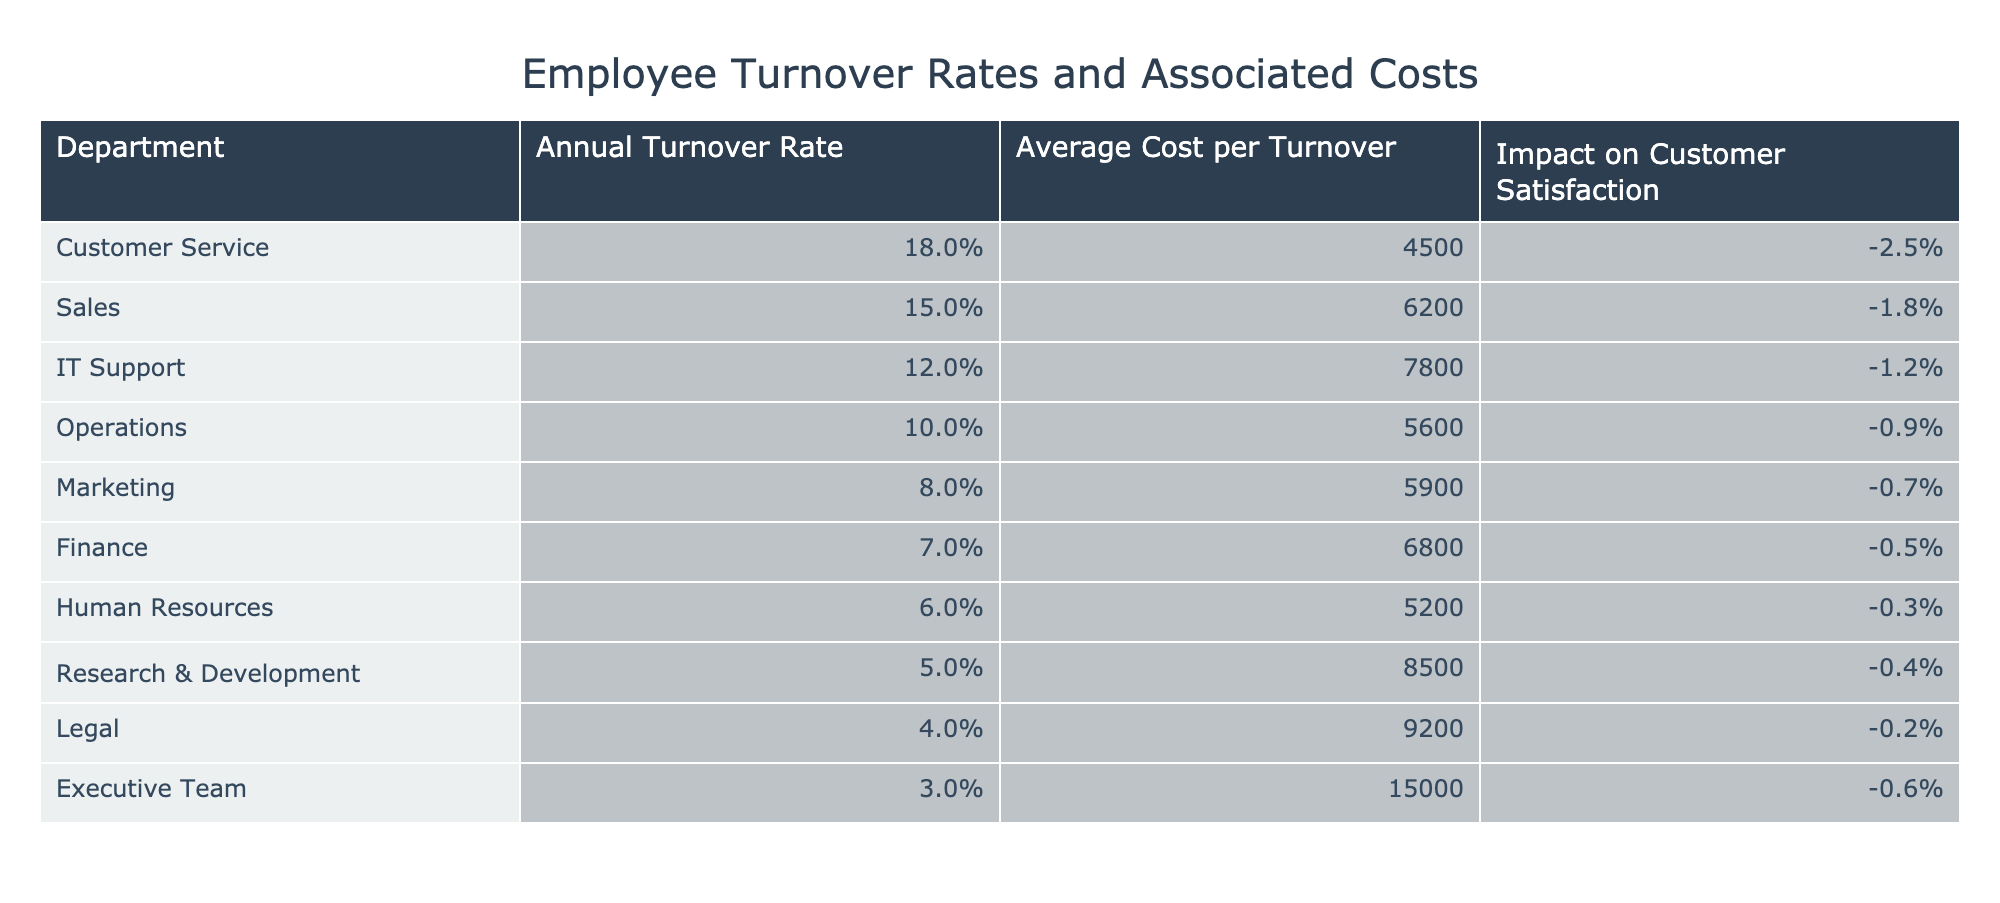What is the annual turnover rate for the Customer Service department? The table shows the "Annual Turnover Rate" for the Customer Service department as 18%.
Answer: 18% Which department has the highest average cost per turnover? The table lists the average cost per turnover for each department. The Executive Team has the highest cost at $15,000.
Answer: $15,000 What is the total impact on customer satisfaction of the Sales and IT Support departments combined? The impact on customer satisfaction for Sales is -1.8% and for IT Support is -1.2%. Adding these gives -1.8% + -1.2% = -3.0%.
Answer: -3.0% Is the average cost per turnover for the Marketing department lower than that of the Finance department? The average cost per turnover for Marketing is $5,900 and for Finance is $6,800. Since $5,900 is less than $6,800, the statement is true.
Answer: Yes How does the turnover rate of the Operations department compare to that of the Marketing department? The Operations department has a turnover rate of 10%, while the Marketing department has a turnover rate of 8%. Thus, Operations has a higher turnover rate than Marketing.
Answer: Higher What is the average annual turnover rate for departments with an impact on customer satisfaction greater than -1%? The departments with an impact greater than -1% are Finance (7%), Human Resources (6%), Research & Development (5%), Legal (4%), and Executive Team (3%). The average is (7 + 6 + 5 + 4 + 3) / 5 = 25 / 5 = 5%.
Answer: 5% What is the difference in average cost per turnover between the departments with the highest and lowest turnover rates? The department with the highest turnover rate is Customer Service with $4,500, and the lowest is Executive Team with $15,000. The difference is $15,000 - $4,500 = $10,500.
Answer: $10,500 Is it true that the IT Support department has a negative impact on customer satisfaction? The table shows that the IT Support department has an impact of -1.2%, which is negative. Therefore, the statement is true.
Answer: Yes What is the average turnover rate for the departments that have a negative impact on customer satisfaction? The departments that negatively impact customer satisfaction are Customer Service (-2.5%), Sales (-1.8%), IT Support (-1.2%), Operations (-0.9%), Marketing (-0.7%), Finance (-0.5%), and Research & Development (-0.4%). The average is (18 + 15 + 12 + 10 + 8 + 7 + 5) / 7 = 75 / 7 ≈ 10.71%.
Answer: 10.71% 